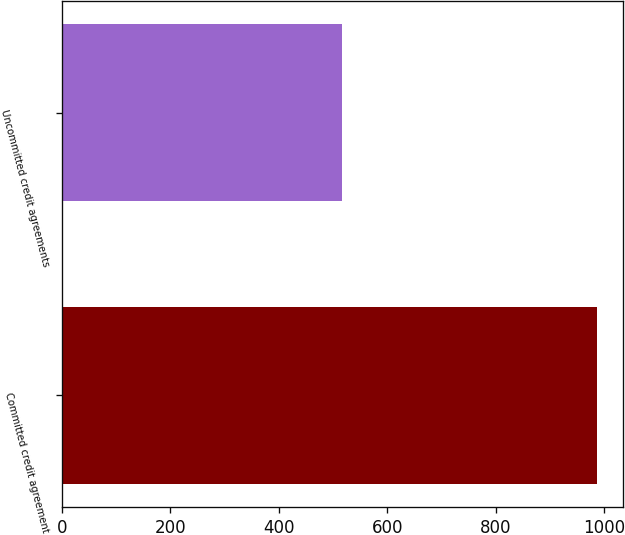Convert chart. <chart><loc_0><loc_0><loc_500><loc_500><bar_chart><fcel>Committed credit agreement<fcel>Uncommitted credit agreements<nl><fcel>985.7<fcel>516.9<nl></chart> 